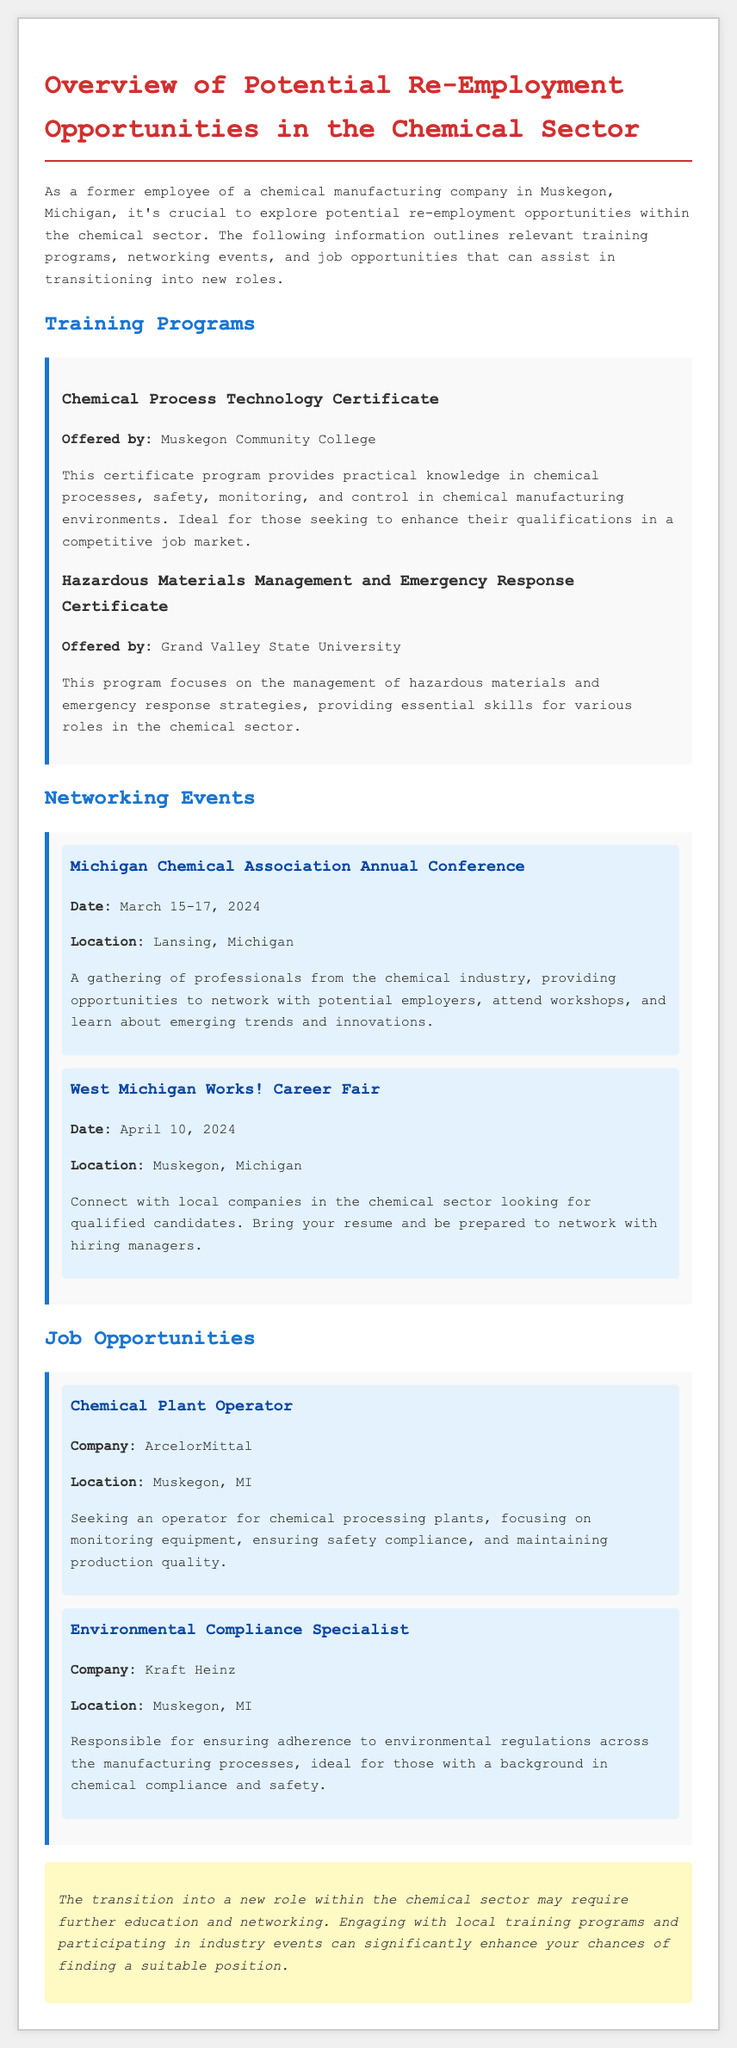What is the title of the memo? The title of the memo is stated at the top of the document.
Answer: Overview of Potential Re-Employment Opportunities in the Chemical Sector Which college offers the Chemical Process Technology Certificate? The document lists the institutions providing the training programs.
Answer: Muskegon Community College What date is the West Michigan Works! Career Fair scheduled for? The event date is provided in the section about networking events.
Answer: April 10, 2024 Which company is hiring for the position of Chemical Plant Operator? The job section specifies the companies offering employment opportunities.
Answer: ArcelorMittal What type of program is offered by Grand Valley State University? The document outlines the training programs available and their focus.
Answer: Hazardous Materials Management and Emergency Response Certificate What city will host the Michigan Chemical Association Annual Conference? The location of the networking event is mentioned in the memo.
Answer: Lansing, Michigan What two main areas does the memo cover? The document is structured into specific areas relevant for job seekers.
Answer: Training programs and networking events What skills does the Hazardous Materials Management program focus on? The description of the training program elaborates on the skills being developed.
Answer: Management of hazardous materials and emergency response strategies 